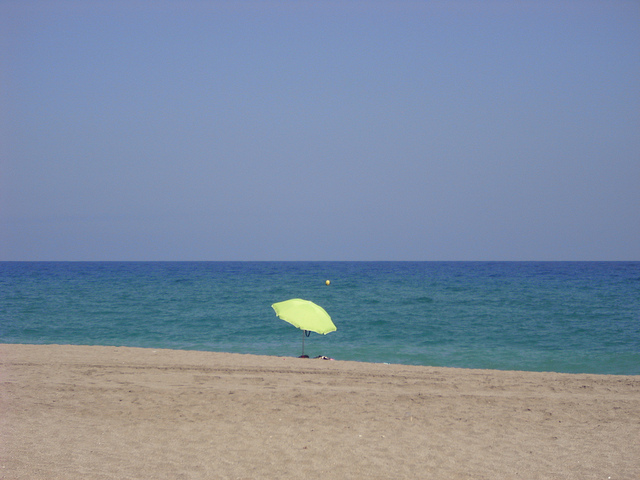What time of day does this scene likely represent? Judging by the lighting and the length of the shadows on the ground, it seems to be midday. The sun appears to be high, suggesting a time around noon or early afternoon. What does the presence of a single umbrella imply about this beach area? The single umbrella may suggest that this is either a relatively less popular stretch of beach or a moment of temporary solitude. It could indicate that it is not peak season, or perhaps it's a weekday when fewer beach-goers are present. 